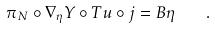Convert formula to latex. <formula><loc_0><loc_0><loc_500><loc_500>\pi _ { N } \circ \nabla _ { \eta } Y \circ T u \circ j = B \eta \quad .</formula> 